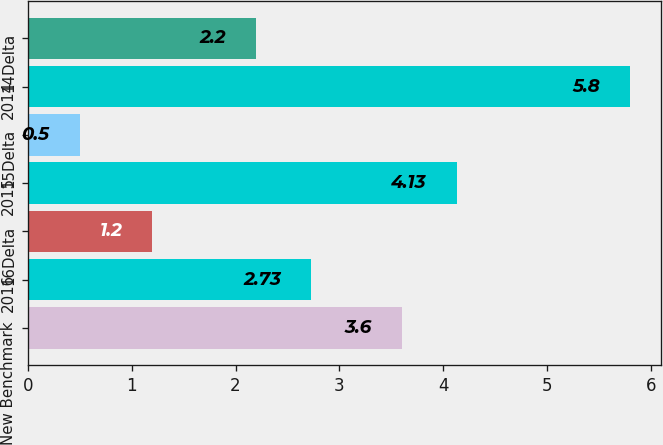Convert chart. <chart><loc_0><loc_0><loc_500><loc_500><bar_chart><fcel>New Benchmark<fcel>2016<fcel>16Delta<fcel>2015<fcel>15Delta<fcel>2014<fcel>14Delta<nl><fcel>3.6<fcel>2.73<fcel>1.2<fcel>4.13<fcel>0.5<fcel>5.8<fcel>2.2<nl></chart> 